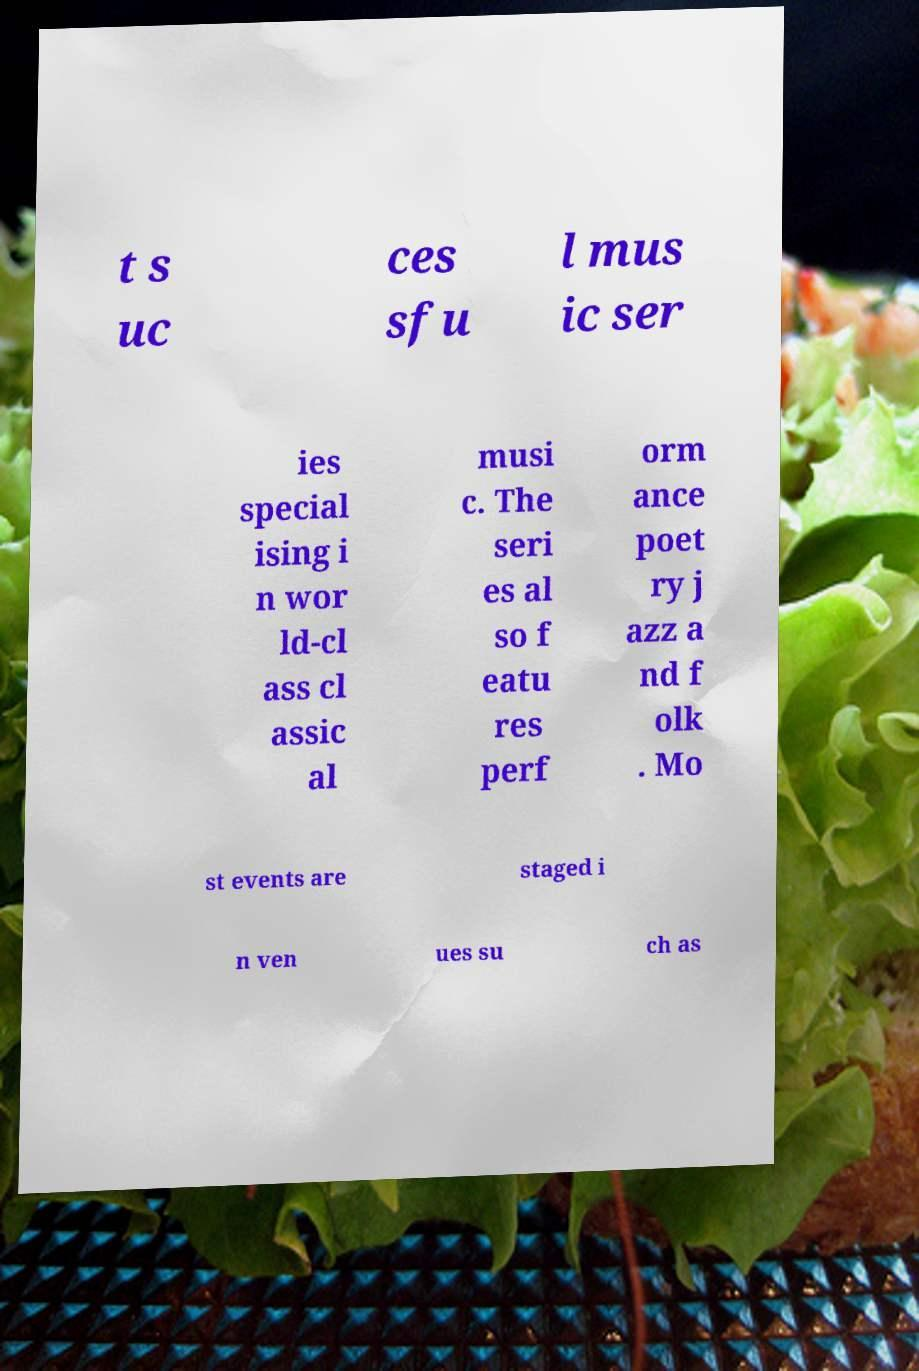Can you accurately transcribe the text from the provided image for me? t s uc ces sfu l mus ic ser ies special ising i n wor ld-cl ass cl assic al musi c. The seri es al so f eatu res perf orm ance poet ry j azz a nd f olk . Mo st events are staged i n ven ues su ch as 